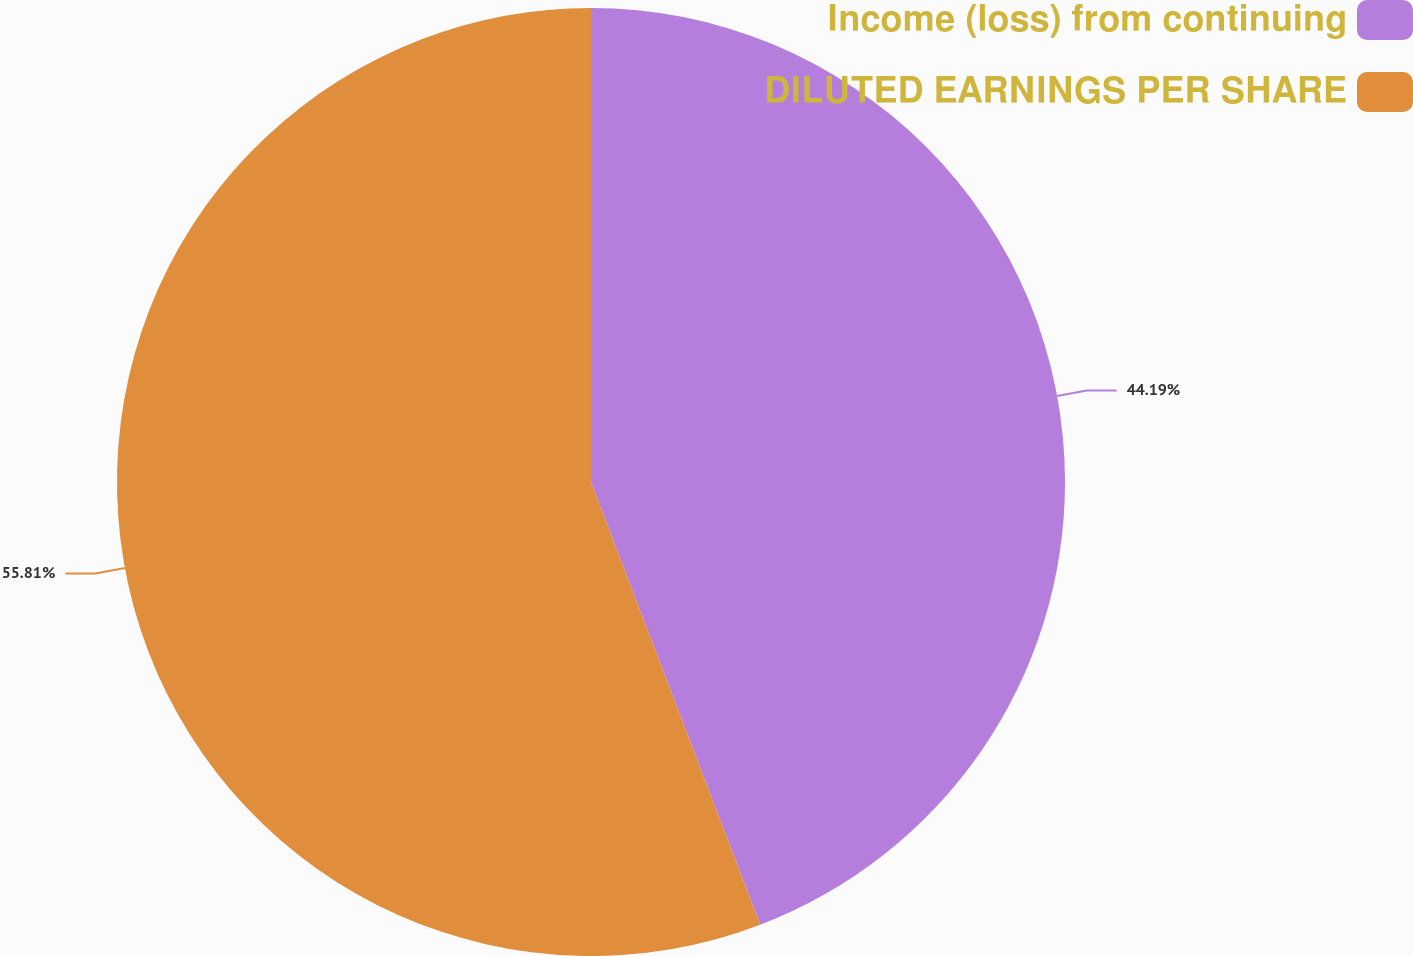Convert chart to OTSL. <chart><loc_0><loc_0><loc_500><loc_500><pie_chart><fcel>Income (loss) from continuing<fcel>DILUTED EARNINGS PER SHARE<nl><fcel>44.19%<fcel>55.81%<nl></chart> 